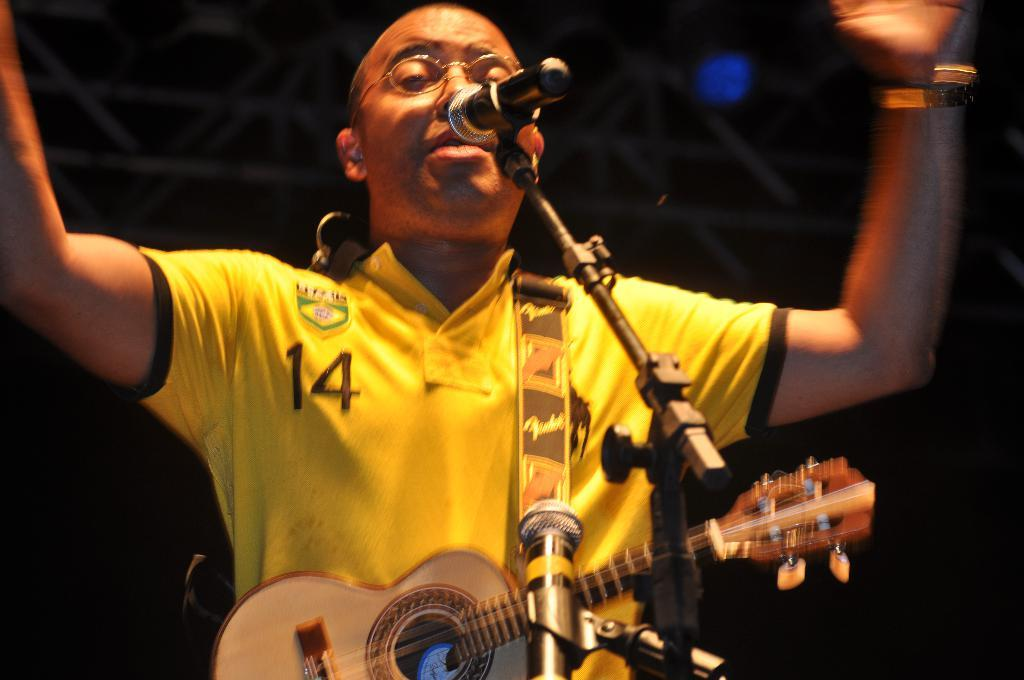Who is the main subject in the image? There is a boy in the image. What is the boy holding in the image? The boy is holding a guitar. What is the boy doing in the image? The boy is singing and using a microphone. What type of crack can be seen on the beast's back in the image? There is no beast or crack present in the image; it features a boy holding a guitar and using a microphone. 